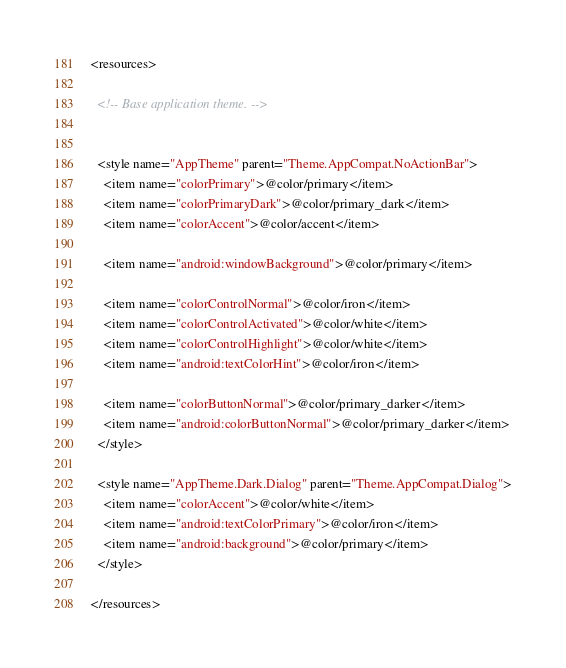Convert code to text. <code><loc_0><loc_0><loc_500><loc_500><_XML_><resources>

  <!-- Base application theme. -->


  <style name="AppTheme" parent="Theme.AppCompat.NoActionBar">
    <item name="colorPrimary">@color/primary</item>
    <item name="colorPrimaryDark">@color/primary_dark</item>
    <item name="colorAccent">@color/accent</item>

    <item name="android:windowBackground">@color/primary</item>

    <item name="colorControlNormal">@color/iron</item>
    <item name="colorControlActivated">@color/white</item>
    <item name="colorControlHighlight">@color/white</item>
    <item name="android:textColorHint">@color/iron</item>

    <item name="colorButtonNormal">@color/primary_darker</item>
    <item name="android:colorButtonNormal">@color/primary_darker</item>
  </style>

  <style name="AppTheme.Dark.Dialog" parent="Theme.AppCompat.Dialog">
    <item name="colorAccent">@color/white</item>
    <item name="android:textColorPrimary">@color/iron</item>
    <item name="android:background">@color/primary</item>
  </style>

</resources>
</code> 